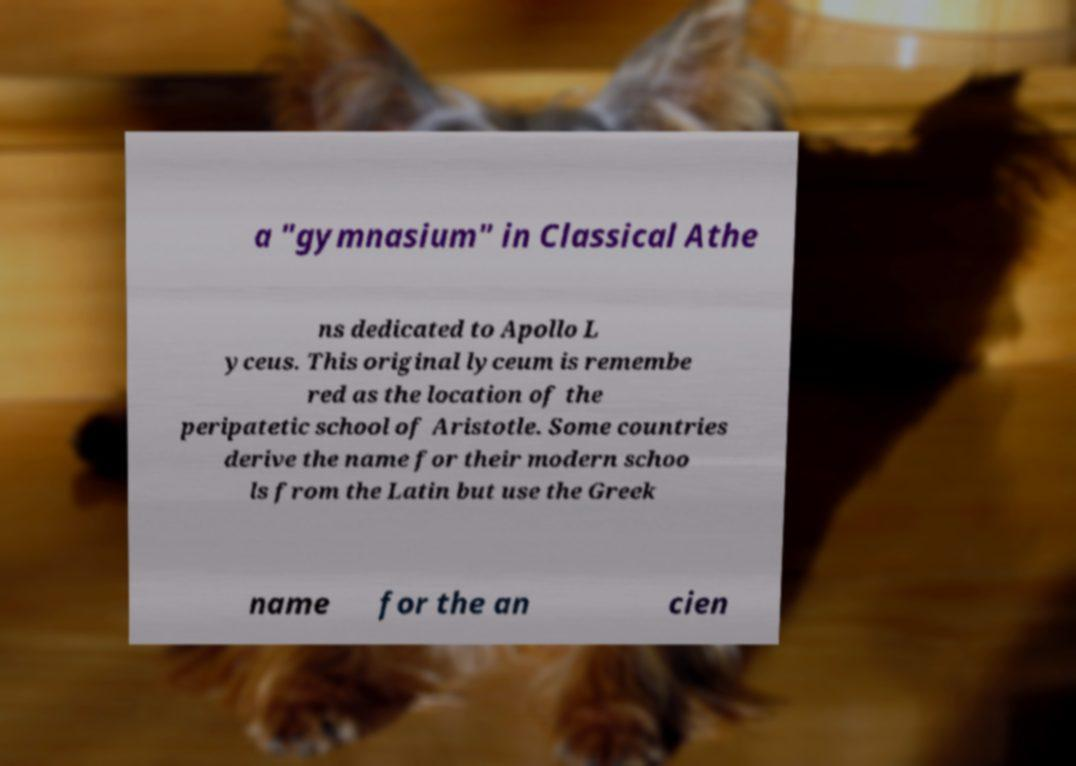What messages or text are displayed in this image? I need them in a readable, typed format. a "gymnasium" in Classical Athe ns dedicated to Apollo L yceus. This original lyceum is remembe red as the location of the peripatetic school of Aristotle. Some countries derive the name for their modern schoo ls from the Latin but use the Greek name for the an cien 